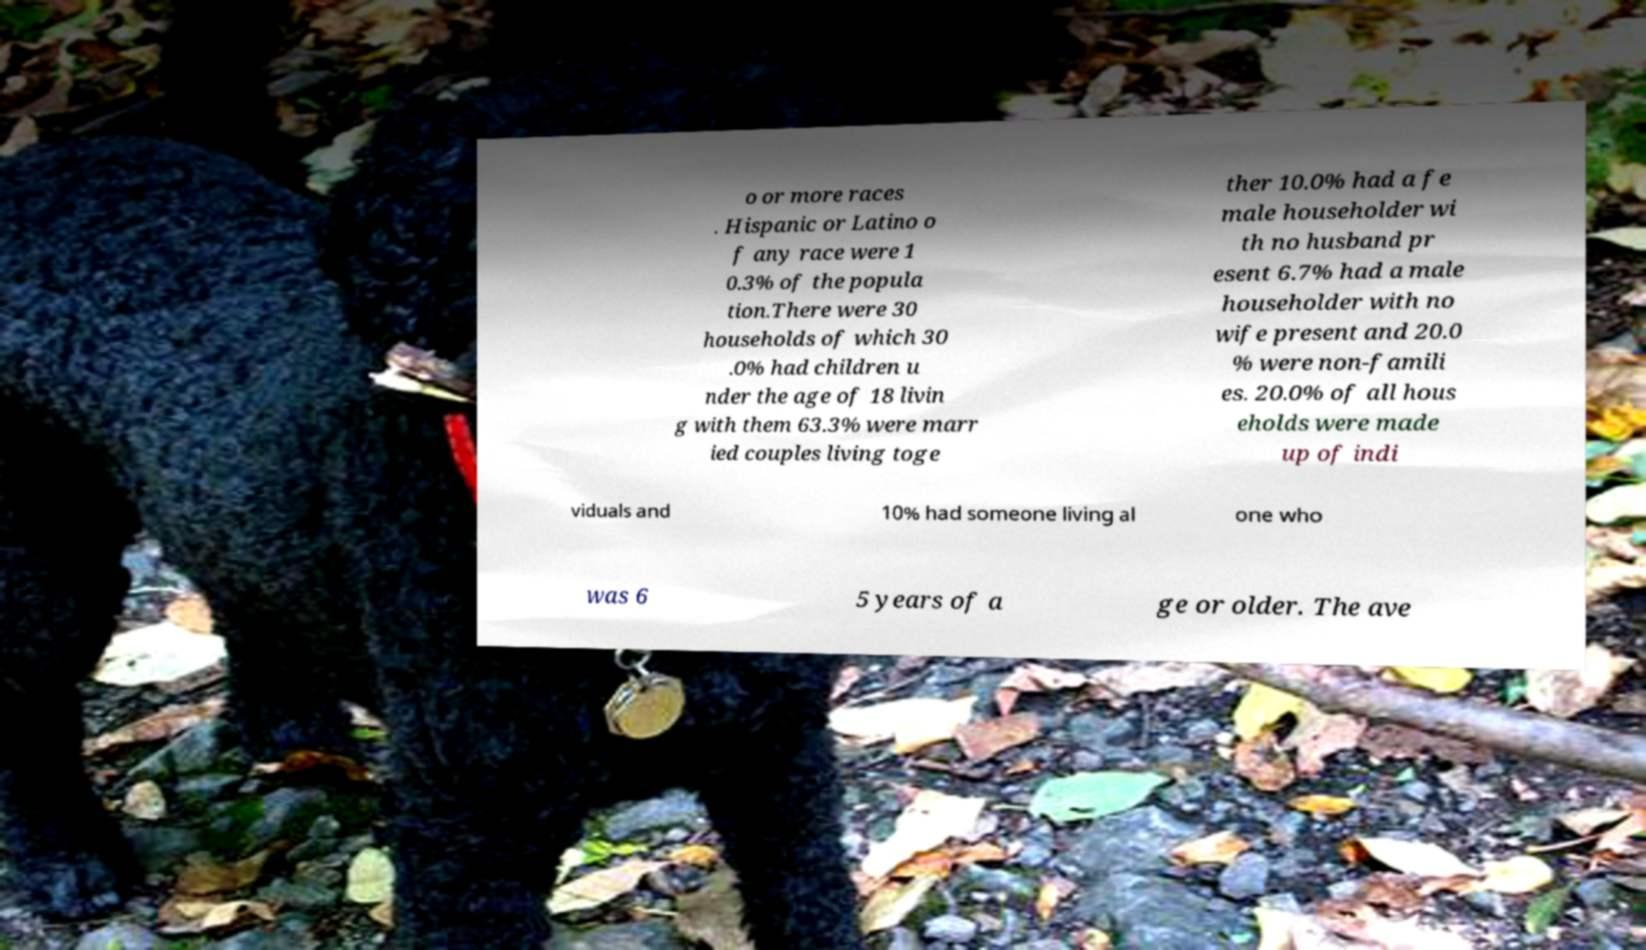Can you accurately transcribe the text from the provided image for me? o or more races . Hispanic or Latino o f any race were 1 0.3% of the popula tion.There were 30 households of which 30 .0% had children u nder the age of 18 livin g with them 63.3% were marr ied couples living toge ther 10.0% had a fe male householder wi th no husband pr esent 6.7% had a male householder with no wife present and 20.0 % were non-famili es. 20.0% of all hous eholds were made up of indi viduals and 10% had someone living al one who was 6 5 years of a ge or older. The ave 